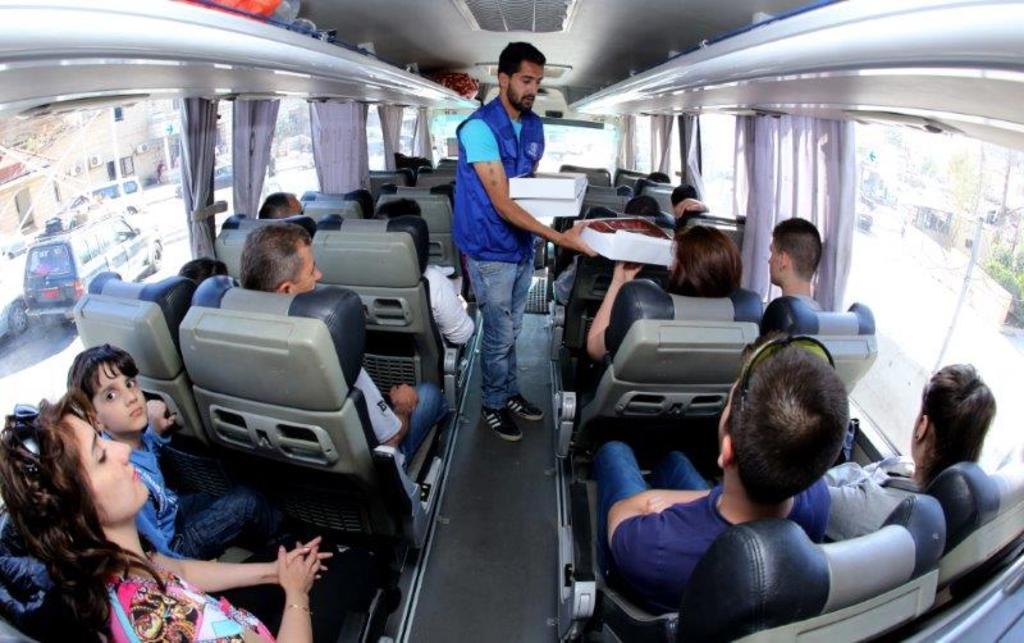Please provide a concise description of this image. This is the inner view of a bus. In the middle of the bus there is a man standing and giving a cardboard carton to a person. In the bus there are persons sitting on the seats in a row. In the background we can see motor vehicles, buildings, windows, poles, trees and road. 